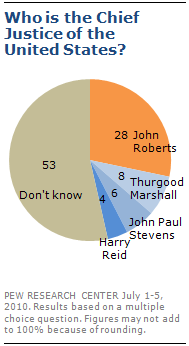Draw attention to some important aspects in this diagram. The color of the 'Don't Know' segment is gray. What is the difference between the two largest segments of 25? 